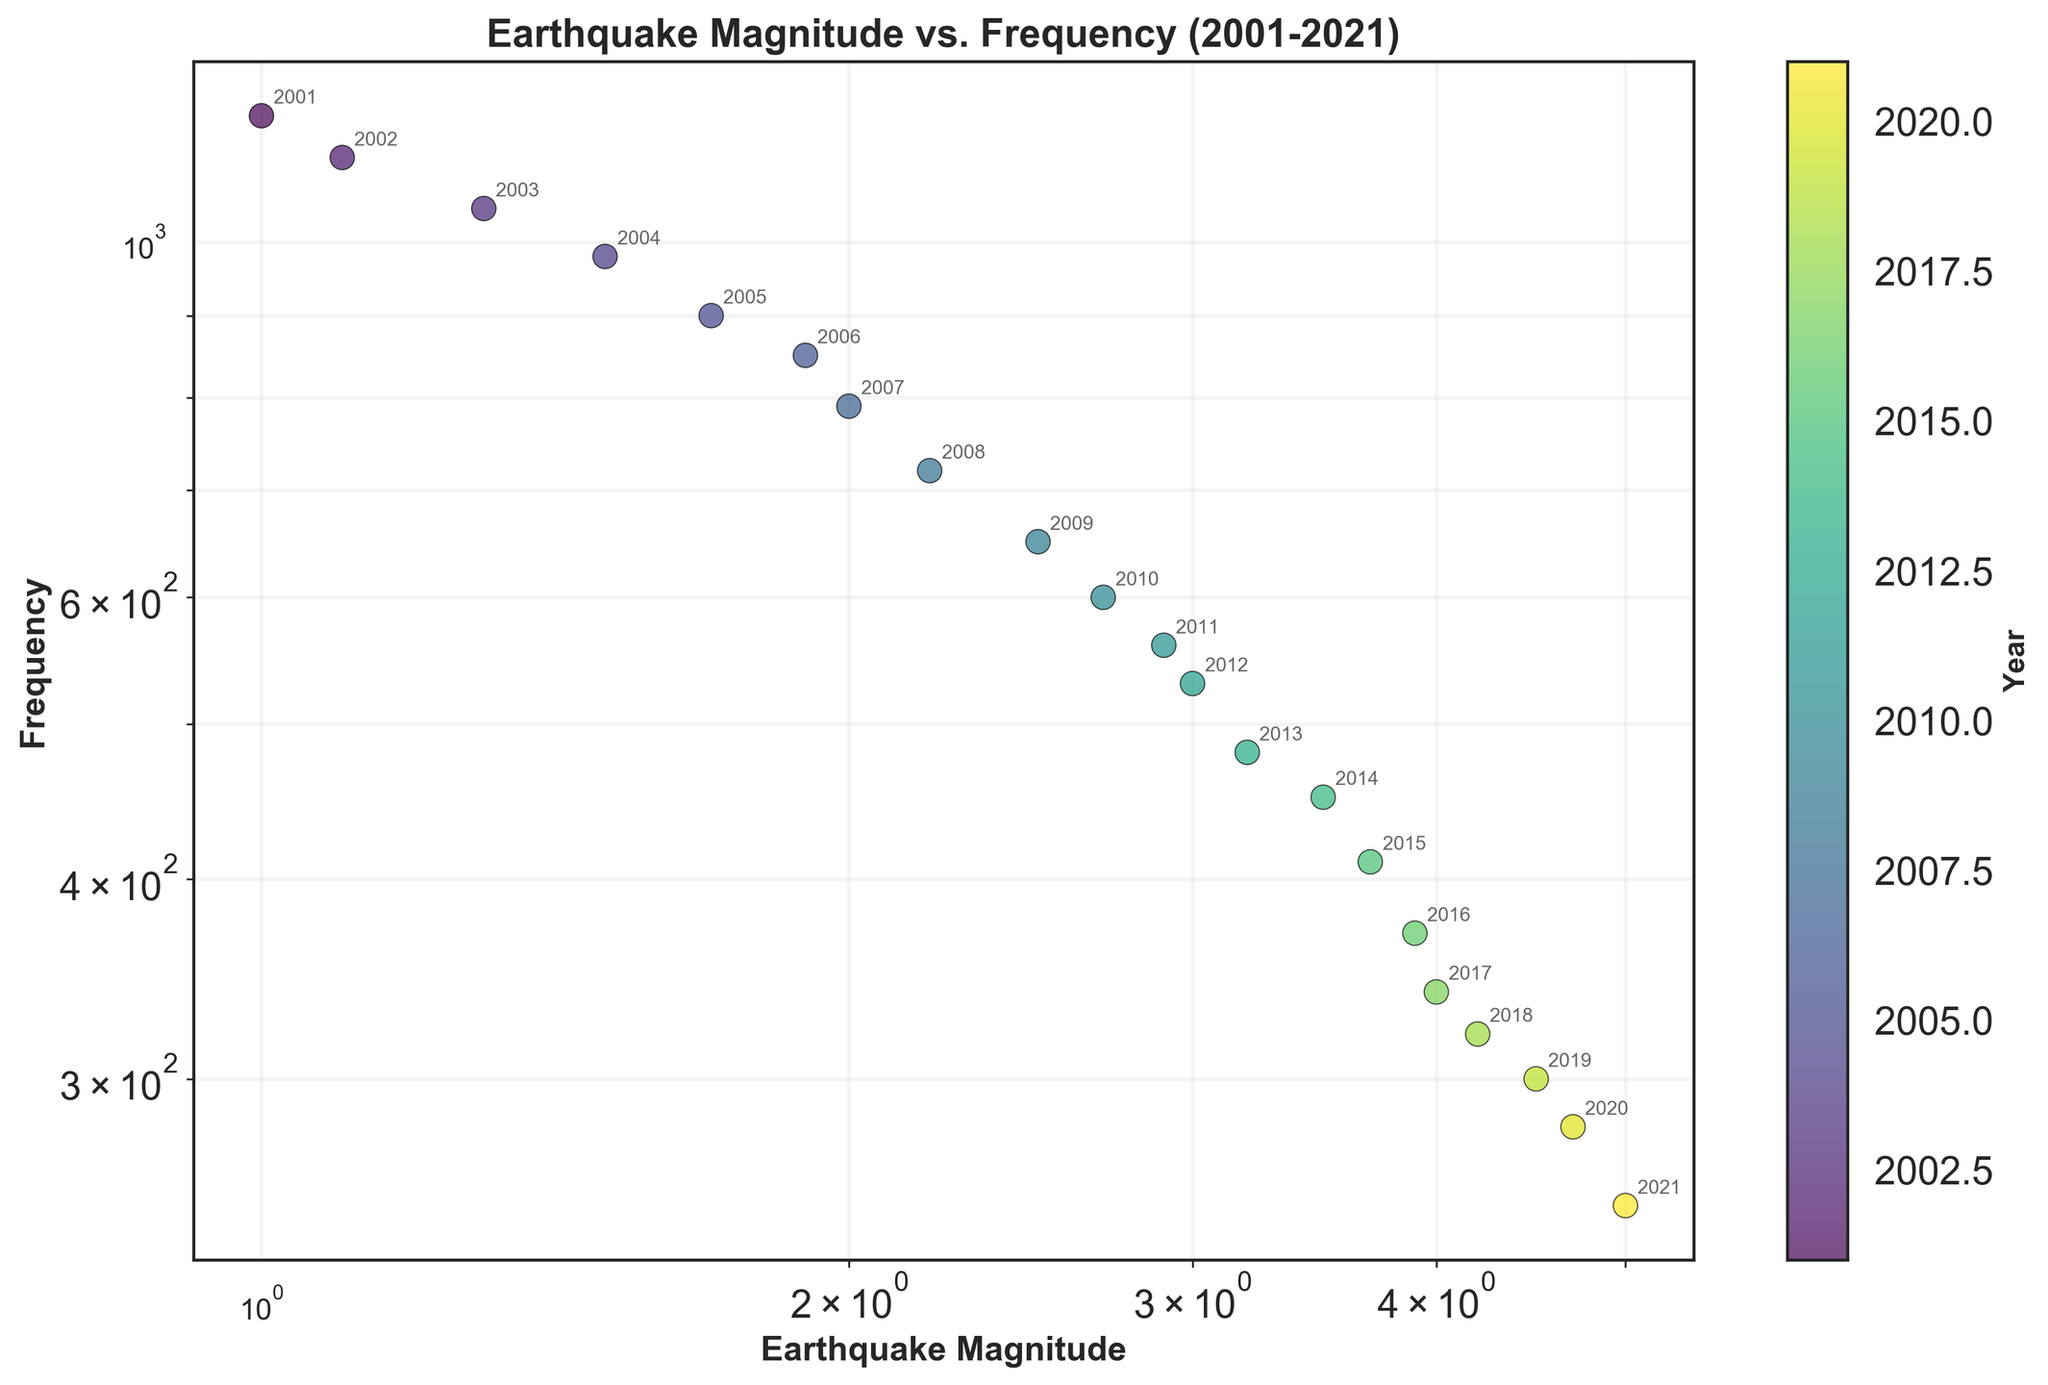What is the title of the figure? The title is usually found at the top of the figure. It summarizes the main topic of the plot. In this case, it indicates that the plot is about earthquake magnitudes vs. frequencies over time.
Answer: Earthquake Magnitude vs. Frequency (2001-2021) Which axis represents earthquake magnitude? The axis representing the earthquake magnitude will usually be labeled and can be found based on the context provided in the title or axis labels. In this plot, it is also given explicitly that the x-axis represents magnitude.
Answer: x-axis Which axis represents frequency? Similar to the previous question, the axis representing the frequency can be derived from the axis label. Here, it is mentioned that the y-axis represents frequency.
Answer: y-axis What is the color of the data points indicating? The legend or color bar will show the meaning of the colors. From the plot description, colors represent different years. The color bar provides a clear gradient from one year to the next.
Answer: Year How many data points are represented in the figure? Each year between 2001 and 2021 inclusively corresponds to one data point. Counting the years listed provides the total number.
Answer: 21 How does frequency change over the years from 2001 to 2021? By observing the data points' colors along with the corresponding frequencies and years, you can see a general trend over time.
Answer: Generally decreases Around which magnitude do earthquakes have the lowest frequency? The scatter plot on a log scale shows lower frequencies towards higher magnitudes. By inspecting the data points, higher magnitudes like 5.0 correspond to lower frequencies.
Answer: 5.0 What trend can you observe between magnitude and frequency? Observing the general position and distribution of data points indicates a trend. On a log scale, this trend can be more linear, indicating an inverse relationship.
Answer: Inversely proportional Is there any year where the frequency significantly deviates from the trend? Anomalies in the trend can be spotted where the frequency significantly deviates from the trendline. Examining such outliers is necessary.
Answer: No significant deviation Which year had the highest frequency of earthquakes? By examining the color and positioning of the data point with the highest frequency along the y-axis, the corresponding year can be identified using the color bar.
Answer: 2001 